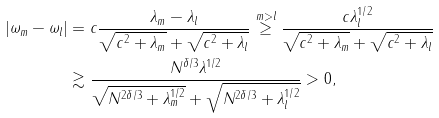Convert formula to latex. <formula><loc_0><loc_0><loc_500><loc_500>| \omega _ { m } - \omega _ { l } | & = c \frac { \lambda _ { m } - \lambda _ { l } } { \sqrt { c ^ { 2 } + \lambda _ { m } } + \sqrt { c ^ { 2 } + \lambda _ { l } } } \stackrel { m > l } { \geq } \frac { c \lambda _ { l } ^ { 1 / 2 } } { \sqrt { c ^ { 2 } + \lambda _ { m } } + \sqrt { c ^ { 2 } + \lambda _ { l } } } \\ & \gtrsim \frac { N ^ { \delta / 3 } \lambda ^ { 1 / 2 } } { \sqrt { N ^ { 2 \delta / 3 } + \lambda _ { m } ^ { 1 / 2 } } + \sqrt { N ^ { 2 \delta / 3 } + \lambda _ { l } ^ { 1 / 2 } } } > 0 ,</formula> 